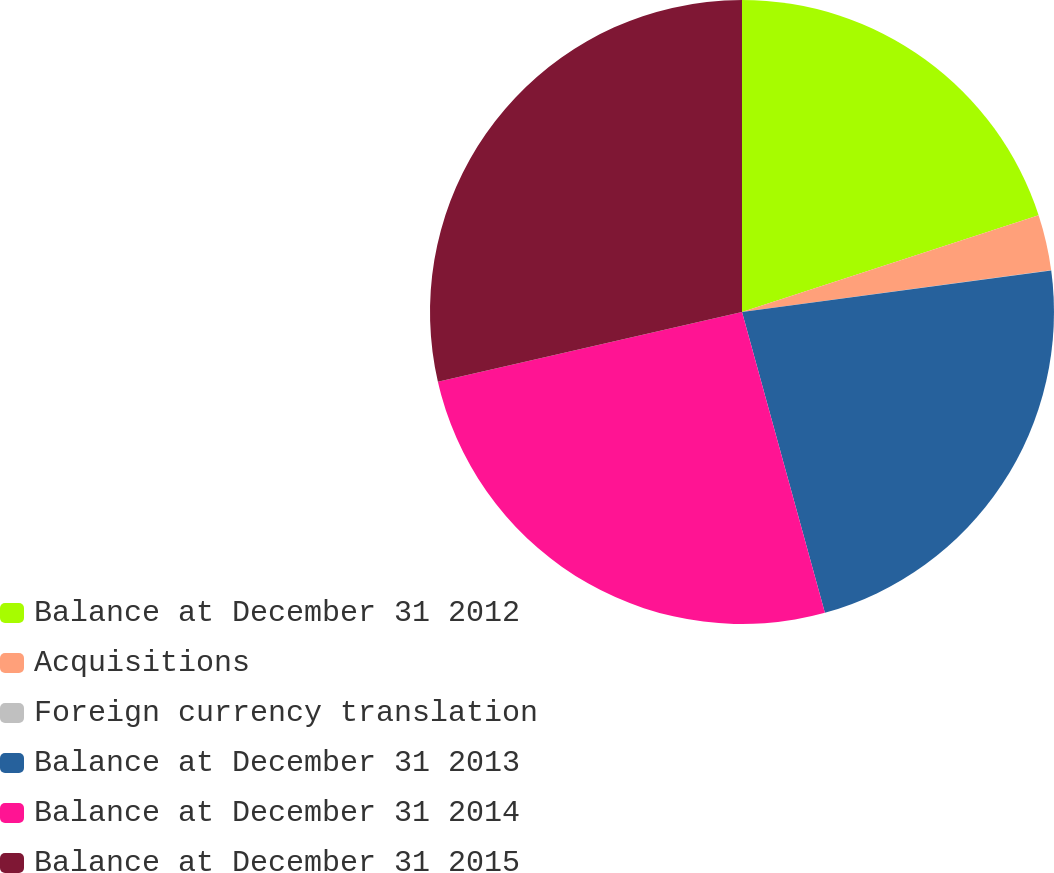Convert chart to OTSL. <chart><loc_0><loc_0><loc_500><loc_500><pie_chart><fcel>Balance at December 31 2012<fcel>Acquisitions<fcel>Foreign currency translation<fcel>Balance at December 31 2013<fcel>Balance at December 31 2014<fcel>Balance at December 31 2015<nl><fcel>19.98%<fcel>2.88%<fcel>0.02%<fcel>22.84%<fcel>25.69%<fcel>28.59%<nl></chart> 